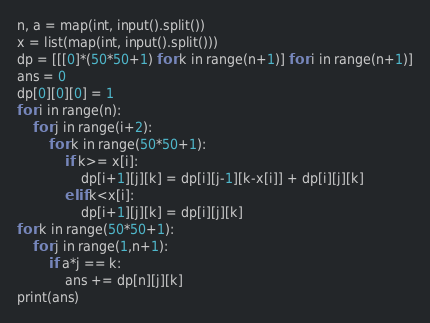<code> <loc_0><loc_0><loc_500><loc_500><_Python_>n, a = map(int, input().split())
x = list(map(int, input().split()))
dp = [[[0]*(50*50+1) for k in range(n+1)] for i in range(n+1)]
ans = 0
dp[0][0][0] = 1
for i in range(n):
    for j in range(i+2):
        for k in range(50*50+1):
            if k>= x[i]:
                dp[i+1][j][k] = dp[i][j-1][k-x[i]] + dp[i][j][k]
            elif k<x[i]:
                dp[i+1][j][k] = dp[i][j][k]
for k in range(50*50+1):
    for j in range(1,n+1):
        if a*j == k:
            ans += dp[n][j][k]
print(ans)</code> 